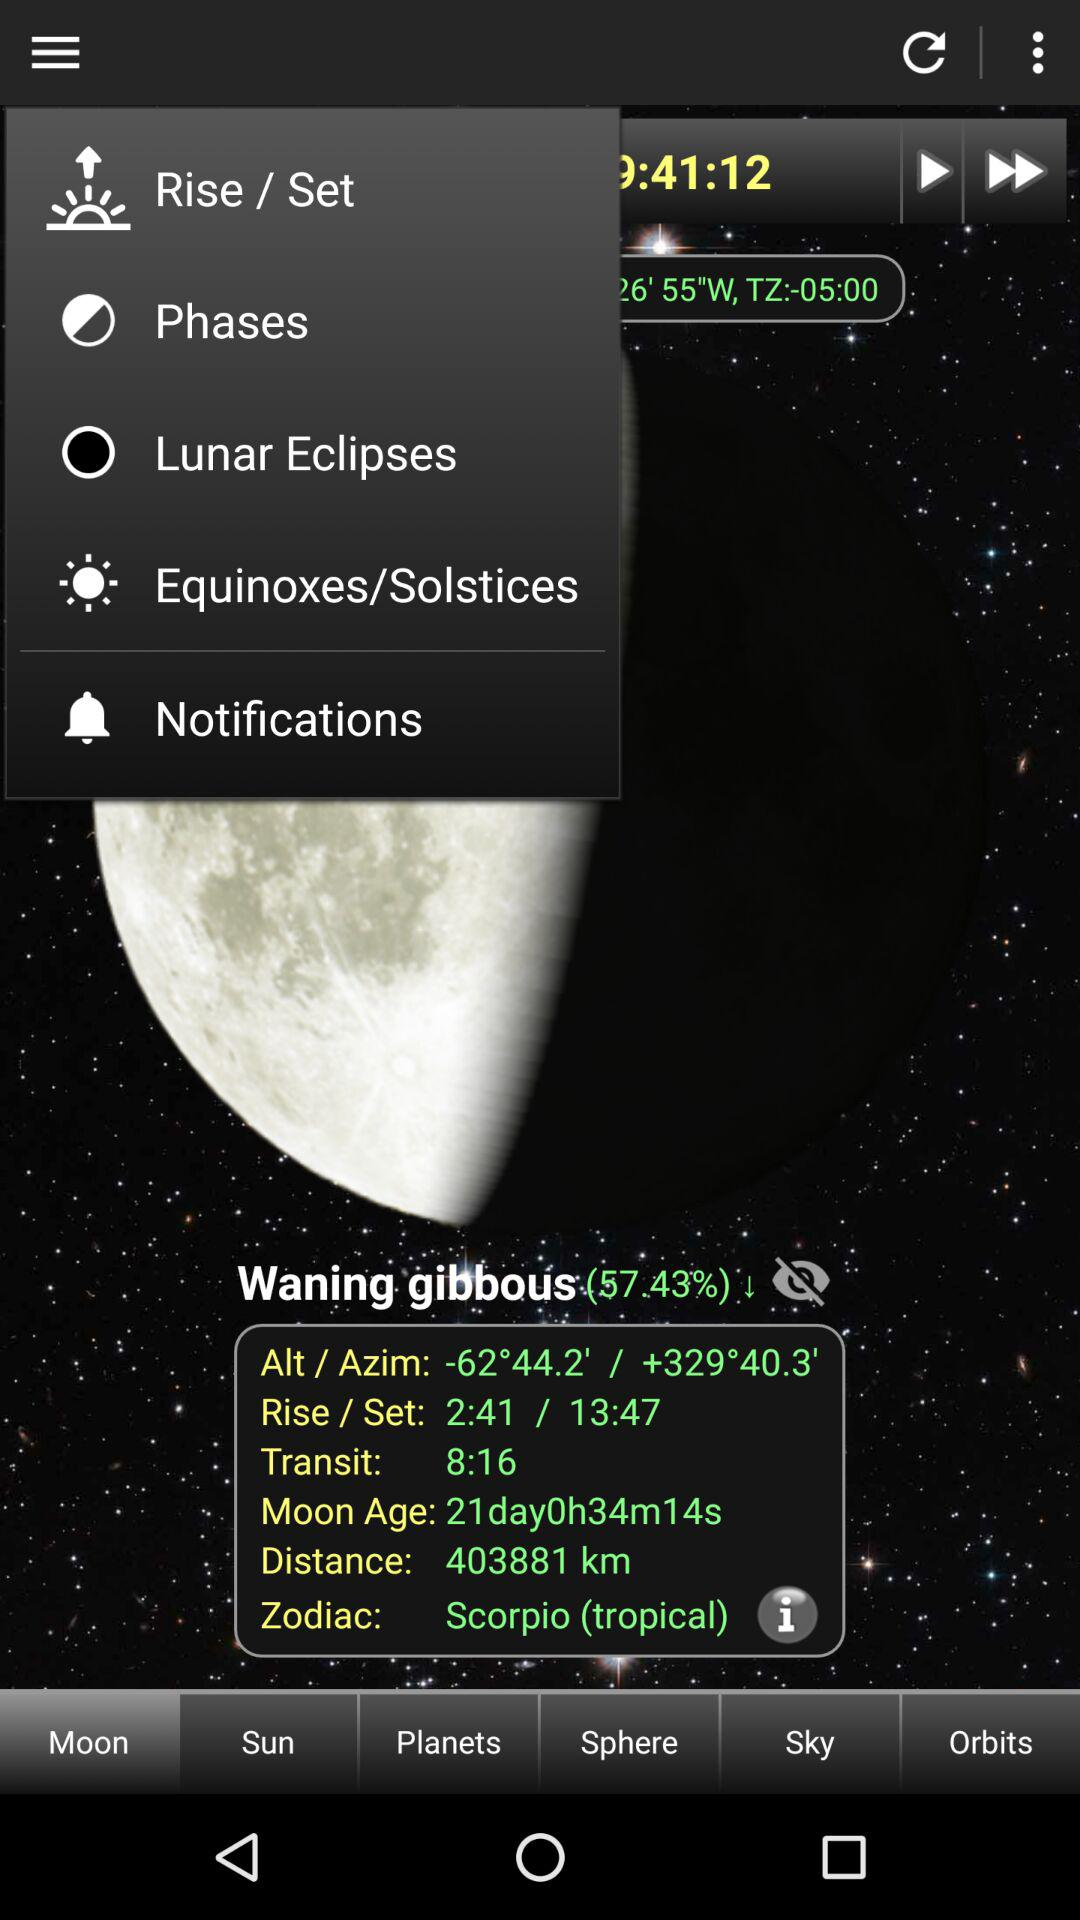What is the Zodiac? The zodiac is "Scorpio (tropical)". 